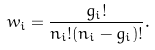Convert formula to latex. <formula><loc_0><loc_0><loc_500><loc_500>w _ { i } = \frac { g _ { i } ! } { n _ { i } ! ( n _ { i } - g _ { i } ) ! } .</formula> 